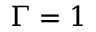<formula> <loc_0><loc_0><loc_500><loc_500>\Gamma = 1</formula> 